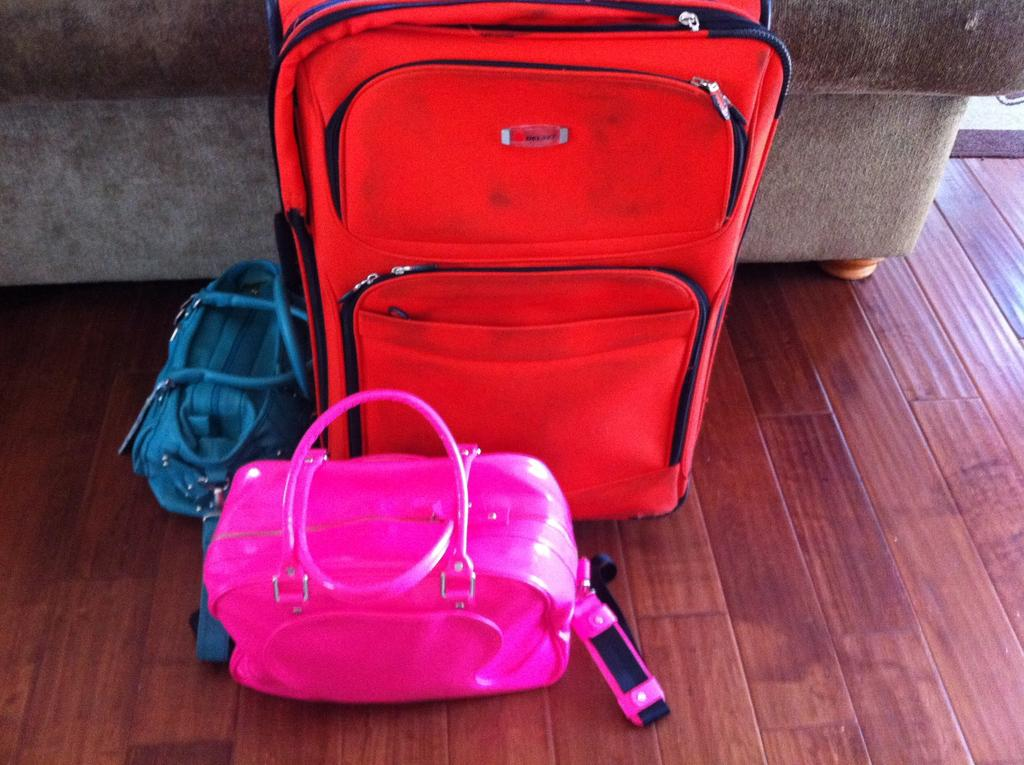What type of bags can be seen in the image? There is a red travel bag, a blue handbag, and a pink handbag in the image. What color is the red bag? The red travel bag is red. What color are the two handbags? The blue handbag is blue, and the pink handbag is pink. What is located behind the bags in the image? There is a sofa behind the bags in the image. Can you see a cat playing with corn on the sofa in the image? No, there is no cat or corn present in the image. 